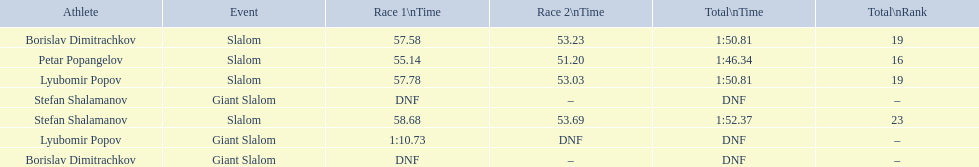Which event is the giant slalom? Giant Slalom, Giant Slalom, Giant Slalom. Which one is lyubomir popov? Lyubomir Popov. What is race 1 tim? 1:10.73. 